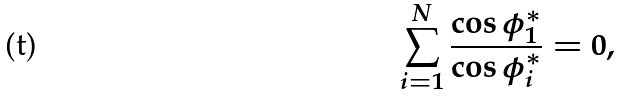<formula> <loc_0><loc_0><loc_500><loc_500>\sum _ { i = 1 } ^ { N } \frac { \cos \phi _ { 1 } ^ { * } } { \cos \phi _ { i } ^ { * } } = 0 ,</formula> 